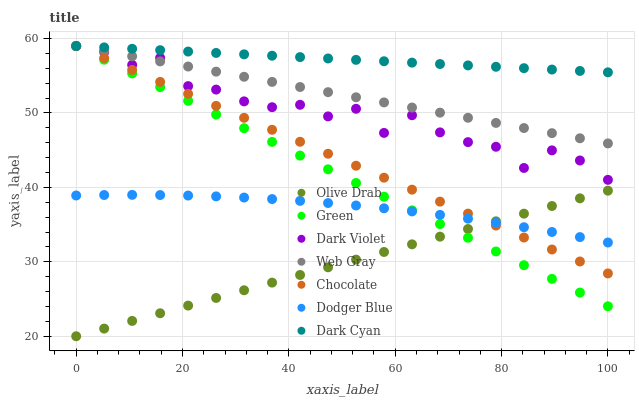Does Olive Drab have the minimum area under the curve?
Answer yes or no. Yes. Does Dark Cyan have the maximum area under the curve?
Answer yes or no. Yes. Does Dark Violet have the minimum area under the curve?
Answer yes or no. No. Does Dark Violet have the maximum area under the curve?
Answer yes or no. No. Is Dark Cyan the smoothest?
Answer yes or no. Yes. Is Dark Violet the roughest?
Answer yes or no. Yes. Is Chocolate the smoothest?
Answer yes or no. No. Is Chocolate the roughest?
Answer yes or no. No. Does Olive Drab have the lowest value?
Answer yes or no. Yes. Does Dark Violet have the lowest value?
Answer yes or no. No. Does Green have the highest value?
Answer yes or no. Yes. Does Dodger Blue have the highest value?
Answer yes or no. No. Is Dodger Blue less than Dark Violet?
Answer yes or no. Yes. Is Dark Cyan greater than Dodger Blue?
Answer yes or no. Yes. Does Olive Drab intersect Green?
Answer yes or no. Yes. Is Olive Drab less than Green?
Answer yes or no. No. Is Olive Drab greater than Green?
Answer yes or no. No. Does Dodger Blue intersect Dark Violet?
Answer yes or no. No. 